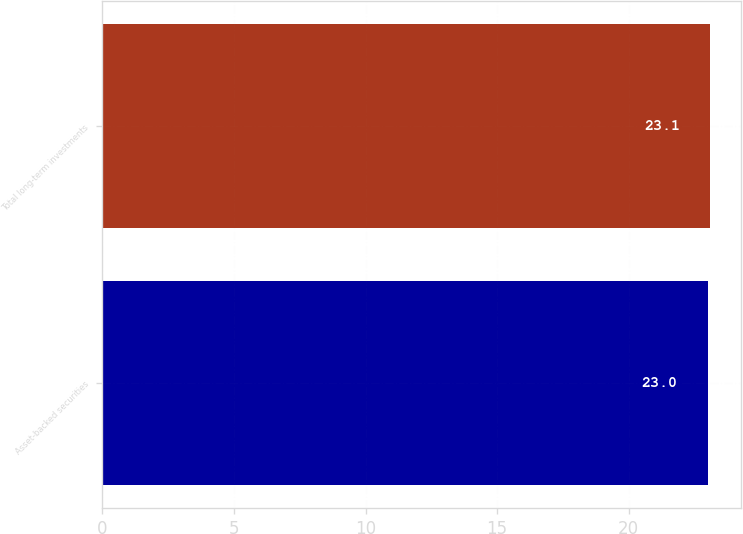Convert chart to OTSL. <chart><loc_0><loc_0><loc_500><loc_500><bar_chart><fcel>Asset-backed securities<fcel>Total long-term investments<nl><fcel>23<fcel>23.1<nl></chart> 